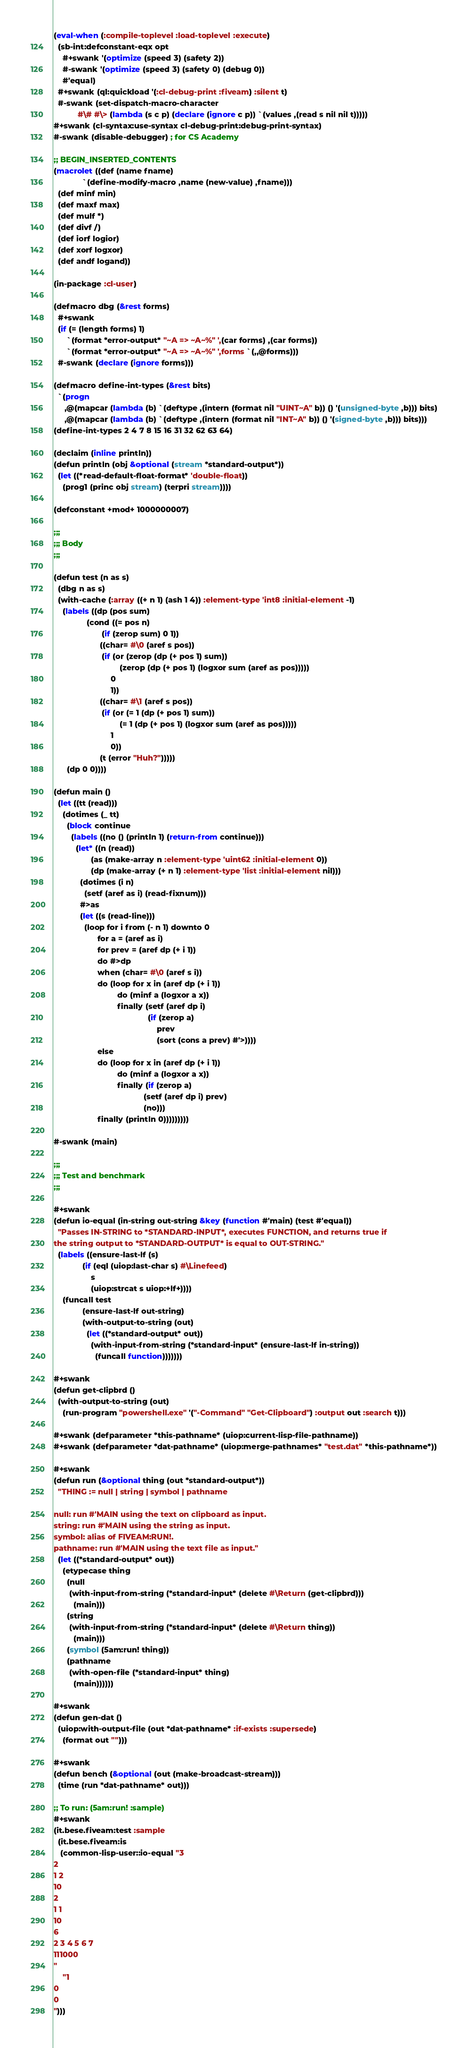Convert code to text. <code><loc_0><loc_0><loc_500><loc_500><_Lisp_>(eval-when (:compile-toplevel :load-toplevel :execute)
  (sb-int:defconstant-eqx opt
    #+swank '(optimize (speed 3) (safety 2))
    #-swank '(optimize (speed 3) (safety 0) (debug 0))
    #'equal)
  #+swank (ql:quickload '(:cl-debug-print :fiveam) :silent t)
  #-swank (set-dispatch-macro-character
           #\# #\> (lambda (s c p) (declare (ignore c p)) `(values ,(read s nil nil t)))))
#+swank (cl-syntax:use-syntax cl-debug-print:debug-print-syntax)
#-swank (disable-debugger) ; for CS Academy

;; BEGIN_INSERTED_CONTENTS
(macrolet ((def (name fname)
             `(define-modify-macro ,name (new-value) ,fname)))
  (def minf min)
  (def maxf max)
  (def mulf *)
  (def divf /)
  (def iorf logior)
  (def xorf logxor)
  (def andf logand))

(in-package :cl-user)

(defmacro dbg (&rest forms)
  #+swank
  (if (= (length forms) 1)
      `(format *error-output* "~A => ~A~%" ',(car forms) ,(car forms))
      `(format *error-output* "~A => ~A~%" ',forms `(,,@forms)))
  #-swank (declare (ignore forms)))

(defmacro define-int-types (&rest bits)
  `(progn
     ,@(mapcar (lambda (b) `(deftype ,(intern (format nil "UINT~A" b)) () '(unsigned-byte ,b))) bits)
     ,@(mapcar (lambda (b) `(deftype ,(intern (format nil "INT~A" b)) () '(signed-byte ,b))) bits)))
(define-int-types 2 4 7 8 15 16 31 32 62 63 64)

(declaim (inline println))
(defun println (obj &optional (stream *standard-output*))
  (let ((*read-default-float-format* 'double-float))
    (prog1 (princ obj stream) (terpri stream))))

(defconstant +mod+ 1000000007)

;;;
;;; Body
;;;

(defun test (n as s)
  (dbg n as s)
  (with-cache (:array ((+ n 1) (ash 1 4)) :element-type 'int8 :initial-element -1)
    (labels ((dp (pos sum)
               (cond ((= pos n)
                      (if (zerop sum) 0 1))
                     ((char= #\0 (aref s pos))
                      (if (or (zerop (dp (+ pos 1) sum))
                              (zerop (dp (+ pos 1) (logxor sum (aref as pos)))))
                          0
                          1))
                     ((char= #\1 (aref s pos))
                      (if (or (= 1 (dp (+ pos 1) sum))
                              (= 1 (dp (+ pos 1) (logxor sum (aref as pos)))))
                          1
                          0))
                     (t (error "Huh?")))))
      (dp 0 0))))

(defun main ()
  (let ((tt (read)))
    (dotimes (_ tt)
      (block continue
        (labels ((no () (println 1) (return-from continue)))
          (let* ((n (read))
                 (as (make-array n :element-type 'uint62 :initial-element 0))
                 (dp (make-array (+ n 1) :element-type 'list :initial-element nil)))
            (dotimes (i n)
              (setf (aref as i) (read-fixnum)))
            #>as
            (let ((s (read-line)))
              (loop for i from (- n 1) downto 0
                    for a = (aref as i)
                    for prev = (aref dp (+ i 1))
                    do #>dp
                    when (char= #\0 (aref s i))
                    do (loop for x in (aref dp (+ i 1))
                             do (minf a (logxor a x))
                             finally (setf (aref dp i)
                                           (if (zerop a)
                                               prev
                                               (sort (cons a prev) #'>))))
                    else
                    do (loop for x in (aref dp (+ i 1))
                             do (minf a (logxor a x))
                             finally (if (zerop a)
                                         (setf (aref dp i) prev)
                                         (no)))
                    finally (println 0)))))))))

#-swank (main)

;;;
;;; Test and benchmark
;;;

#+swank
(defun io-equal (in-string out-string &key (function #'main) (test #'equal))
  "Passes IN-STRING to *STANDARD-INPUT*, executes FUNCTION, and returns true if
the string output to *STANDARD-OUTPUT* is equal to OUT-STRING."
  (labels ((ensure-last-lf (s)
             (if (eql (uiop:last-char s) #\Linefeed)
                 s
                 (uiop:strcat s uiop:+lf+))))
    (funcall test
             (ensure-last-lf out-string)
             (with-output-to-string (out)
               (let ((*standard-output* out))
                 (with-input-from-string (*standard-input* (ensure-last-lf in-string))
                   (funcall function)))))))

#+swank
(defun get-clipbrd ()
  (with-output-to-string (out)
    (run-program "powershell.exe" '("-Command" "Get-Clipboard") :output out :search t)))

#+swank (defparameter *this-pathname* (uiop:current-lisp-file-pathname))
#+swank (defparameter *dat-pathname* (uiop:merge-pathnames* "test.dat" *this-pathname*))

#+swank
(defun run (&optional thing (out *standard-output*))
  "THING := null | string | symbol | pathname

null: run #'MAIN using the text on clipboard as input.
string: run #'MAIN using the string as input.
symbol: alias of FIVEAM:RUN!.
pathname: run #'MAIN using the text file as input."
  (let ((*standard-output* out))
    (etypecase thing
      (null
       (with-input-from-string (*standard-input* (delete #\Return (get-clipbrd)))
         (main)))
      (string
       (with-input-from-string (*standard-input* (delete #\Return thing))
         (main)))
      (symbol (5am:run! thing))
      (pathname
       (with-open-file (*standard-input* thing)
         (main))))))

#+swank
(defun gen-dat ()
  (uiop:with-output-file (out *dat-pathname* :if-exists :supersede)
    (format out "")))

#+swank
(defun bench (&optional (out (make-broadcast-stream)))
  (time (run *dat-pathname* out)))

;; To run: (5am:run! :sample)
#+swank
(it.bese.fiveam:test :sample
  (it.bese.fiveam:is
   (common-lisp-user::io-equal "3
2
1 2
10
2
1 1
10
6
2 3 4 5 6 7
111000
"
    "1
0
0
")))
</code> 